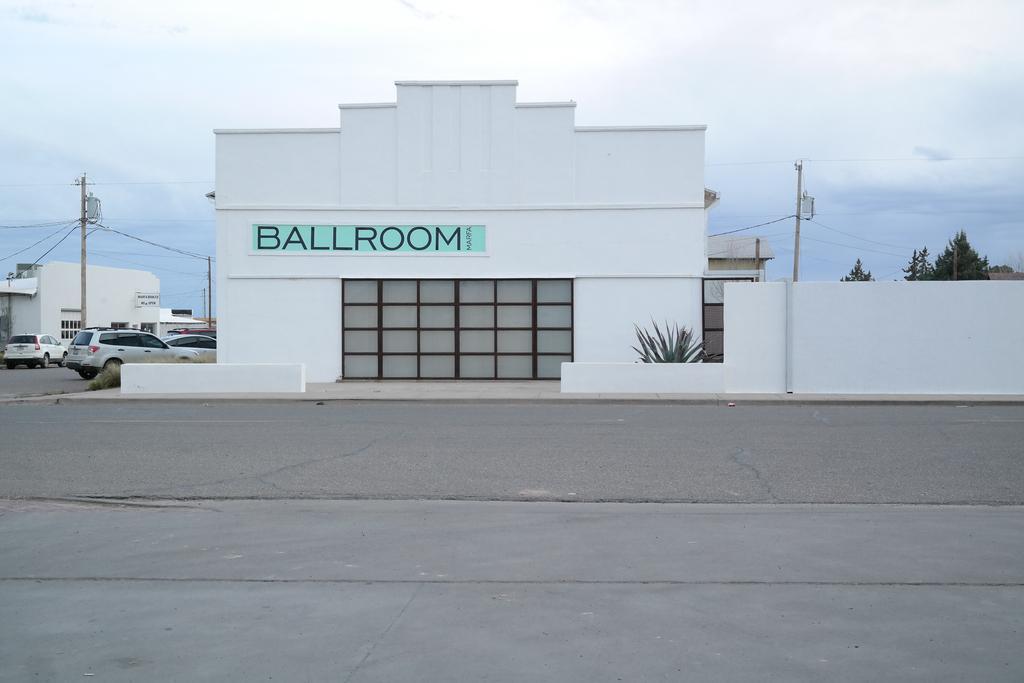Could you give a brief overview of what you see in this image? In the center of the image we can see buildings. On the left there are cars on the road and we can see poles, trees and a plant. At the top there is sky and wires. 